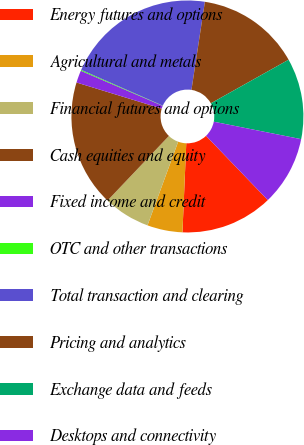<chart> <loc_0><loc_0><loc_500><loc_500><pie_chart><fcel>Energy futures and options<fcel>Agricultural and metals<fcel>Financial futures and options<fcel>Cash equities and equity<fcel>Fixed income and credit<fcel>OTC and other transactions<fcel>Total transaction and clearing<fcel>Pricing and analytics<fcel>Exchange data and feeds<fcel>Desktops and connectivity<nl><fcel>12.87%<fcel>4.91%<fcel>6.5%<fcel>17.64%<fcel>1.72%<fcel>0.13%<fcel>20.83%<fcel>14.46%<fcel>11.27%<fcel>9.68%<nl></chart> 